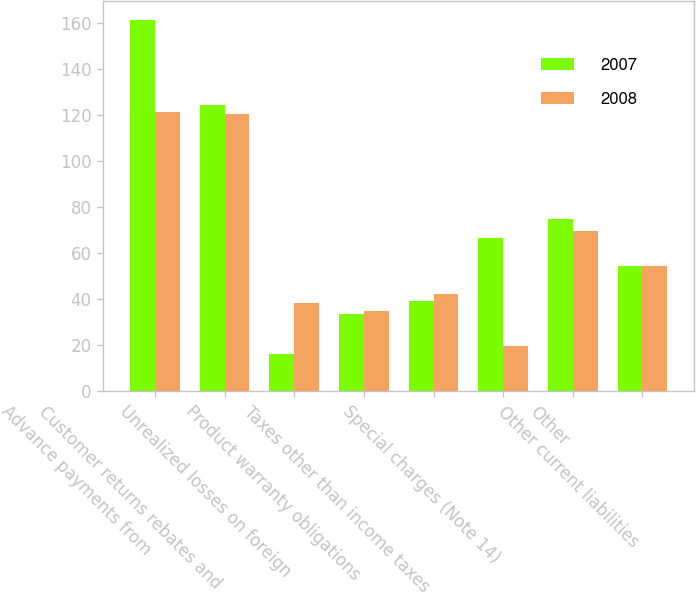Convert chart to OTSL. <chart><loc_0><loc_0><loc_500><loc_500><stacked_bar_chart><ecel><fcel>Advance payments from<fcel>Customer returns rebates and<fcel>Unrealized losses on foreign<fcel>Product warranty obligations<fcel>Taxes other than income taxes<fcel>Special charges (Note 14)<fcel>Other<fcel>Other current liabilities<nl><fcel>2007<fcel>161.6<fcel>124.6<fcel>16.2<fcel>33.5<fcel>39.1<fcel>66.5<fcel>74.8<fcel>54.35<nl><fcel>2008<fcel>121.5<fcel>120.5<fcel>38.2<fcel>34.9<fcel>42.2<fcel>19.6<fcel>69.5<fcel>54.35<nl></chart> 